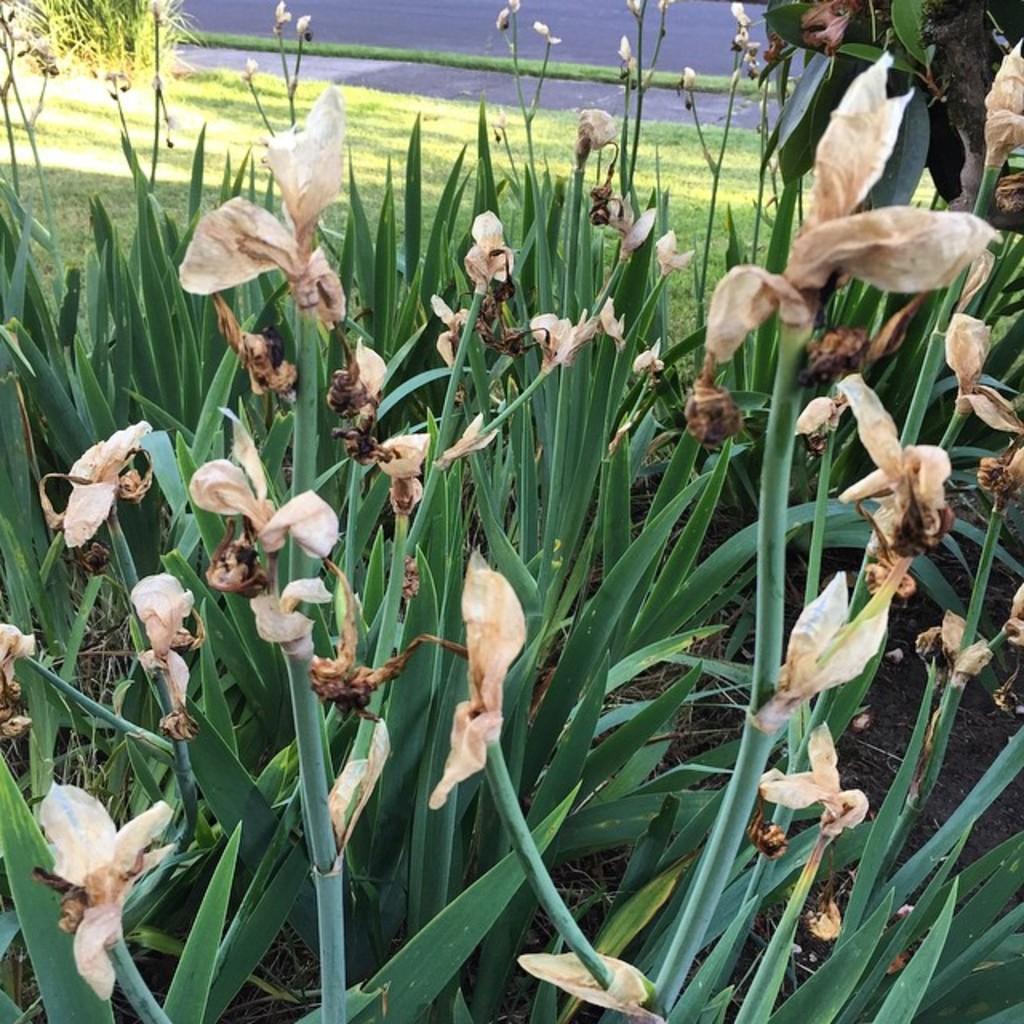In one or two sentences, can you explain what this image depicts? In this picture, we can see some plants, dry flowers, and the ground with grass, and the road. 